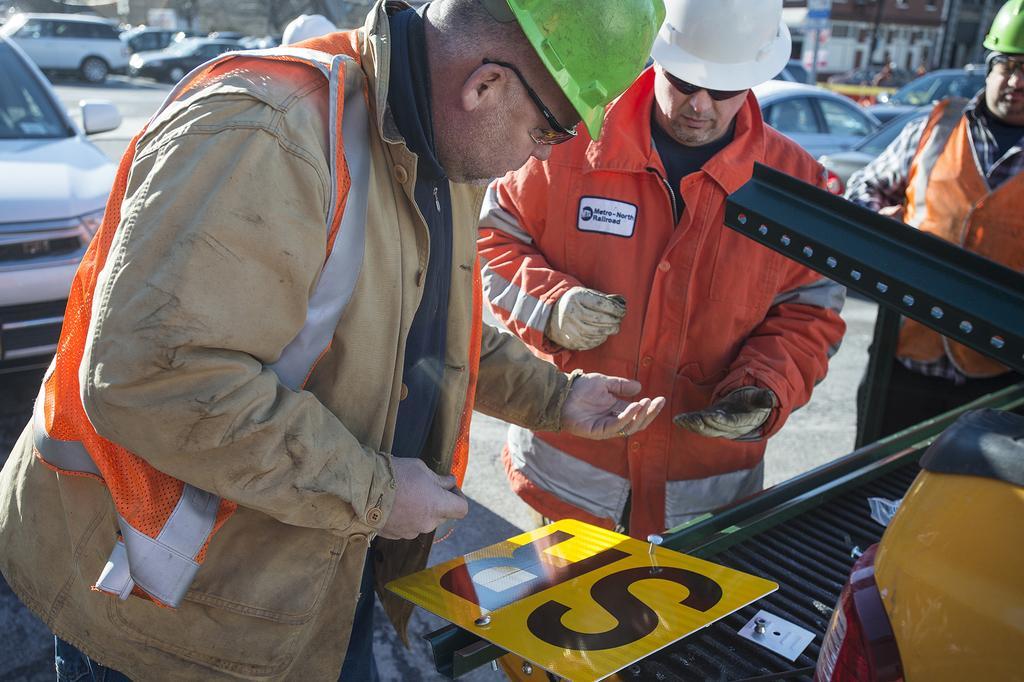Could you give a brief overview of what you see in this image? In this image I can see on the left side a man is standing, he wore a coat. In the middle there is another man, he wore orange color coat, white color helmet. At the top there are cars, at the bottom there is the black color and yellow color board. 